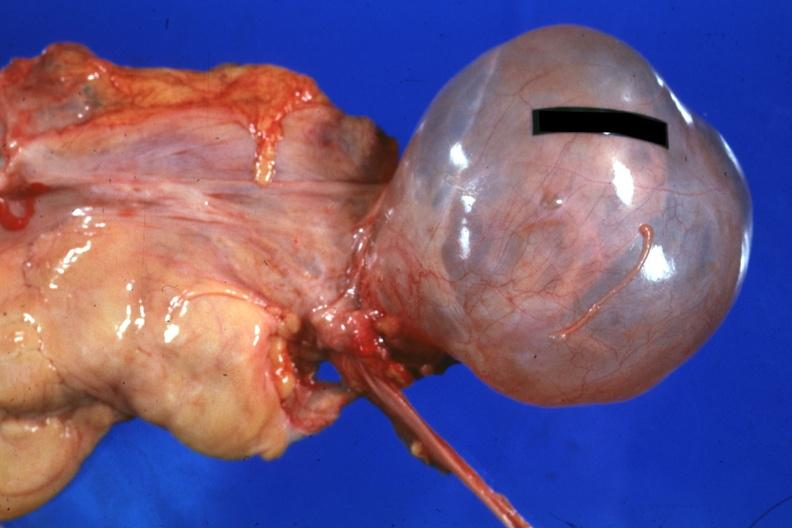where does this part belong to?
Answer the question using a single word or phrase. Female reproductive system 